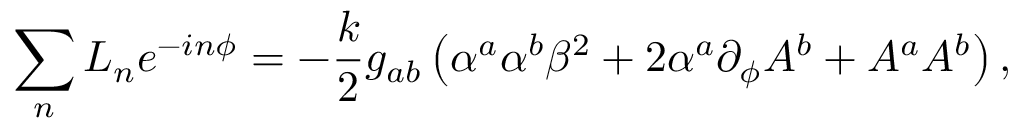Convert formula to latex. <formula><loc_0><loc_0><loc_500><loc_500>\sum _ { n } L _ { n } e ^ { - i n \phi } = - { \frac { k } { 2 } } g _ { a b } \left ( \alpha ^ { a } \alpha ^ { b } \beta ^ { 2 } + 2 \alpha ^ { a } \partial _ { \phi } A ^ { b } + A ^ { a } A ^ { b } \right ) ,</formula> 